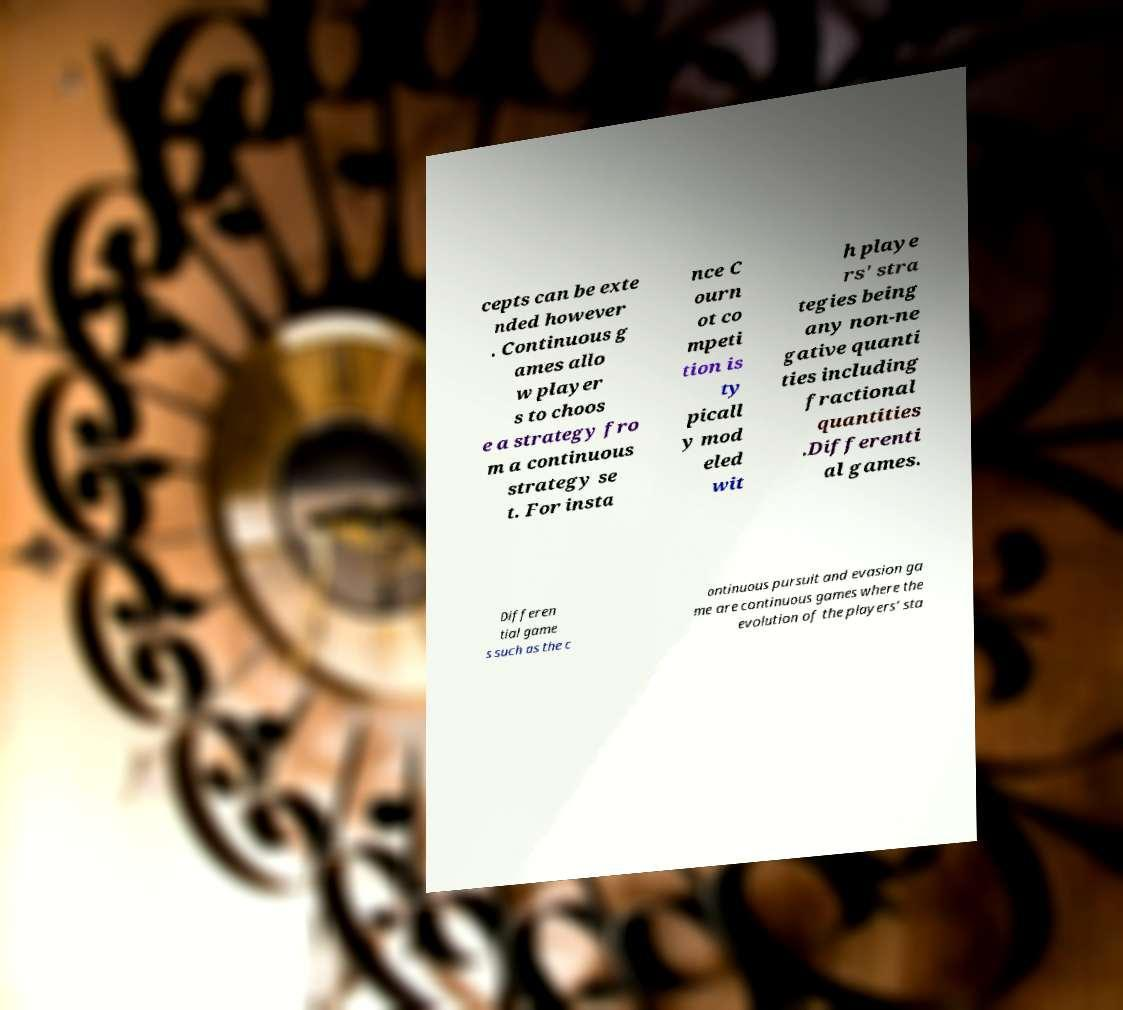Please identify and transcribe the text found in this image. cepts can be exte nded however . Continuous g ames allo w player s to choos e a strategy fro m a continuous strategy se t. For insta nce C ourn ot co mpeti tion is ty picall y mod eled wit h playe rs' stra tegies being any non-ne gative quanti ties including fractional quantities .Differenti al games. Differen tial game s such as the c ontinuous pursuit and evasion ga me are continuous games where the evolution of the players' sta 